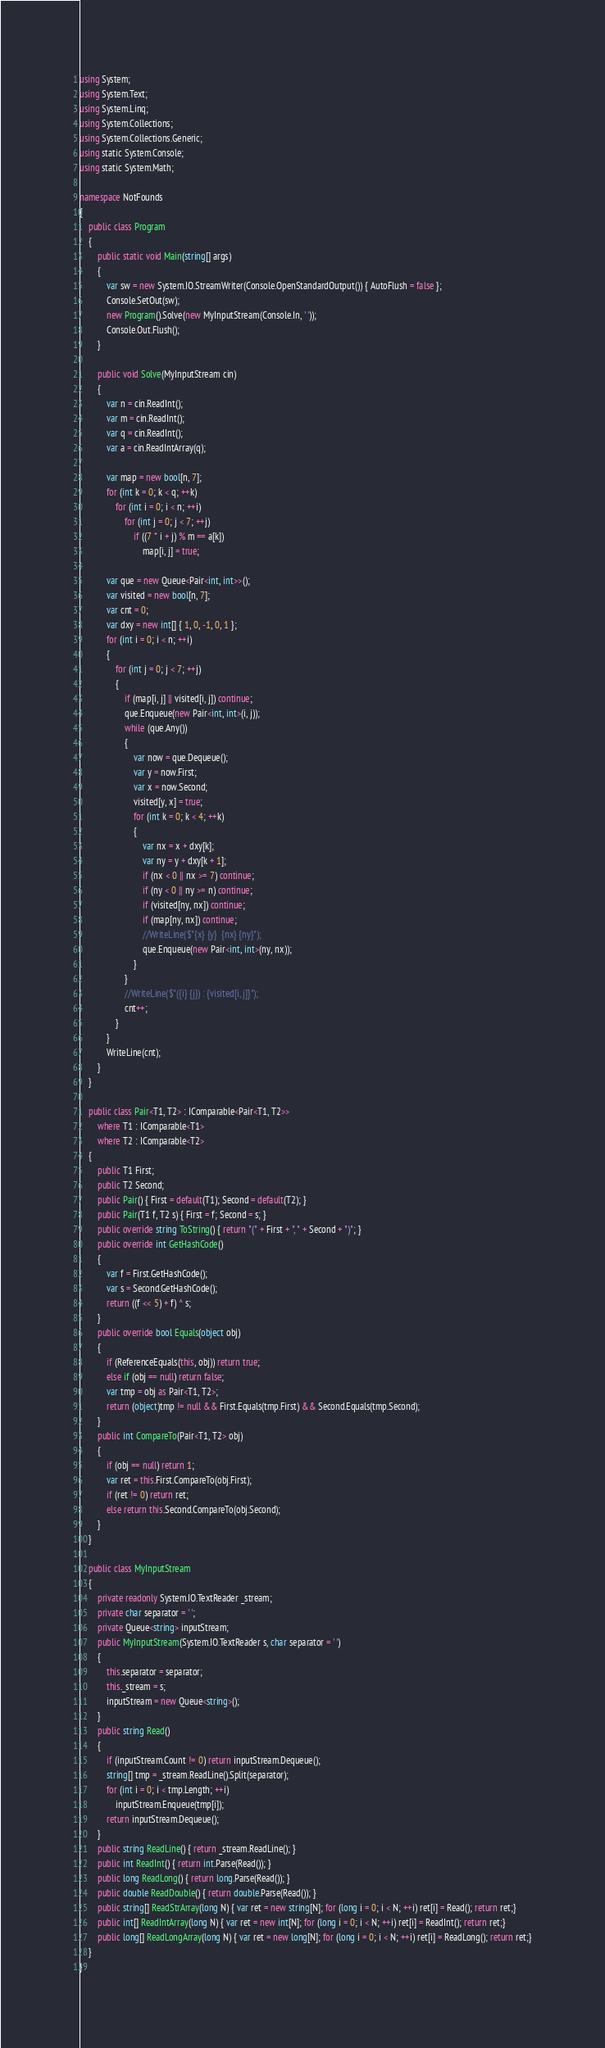Convert code to text. <code><loc_0><loc_0><loc_500><loc_500><_C#_>using System;
using System.Text;
using System.Linq;
using System.Collections;
using System.Collections.Generic;
using static System.Console;
using static System.Math;

namespace NotFounds
{
    public class Program
    {
        public static void Main(string[] args)
        {
            var sw = new System.IO.StreamWriter(Console.OpenStandardOutput()) { AutoFlush = false };
            Console.SetOut(sw);
            new Program().Solve(new MyInputStream(Console.In, ' '));
            Console.Out.Flush();
        }

        public void Solve(MyInputStream cin)
        {
            var n = cin.ReadInt();
            var m = cin.ReadInt();
            var q = cin.ReadInt();
            var a = cin.ReadIntArray(q);

            var map = new bool[n, 7];
            for (int k = 0; k < q; ++k)
                for (int i = 0; i < n; ++i)
                    for (int j = 0; j < 7; ++j)
                        if ((7 * i + j) % m == a[k])
                            map[i, j] = true;

            var que = new Queue<Pair<int, int>>();
            var visited = new bool[n, 7];
            var cnt = 0;
            var dxy = new int[] { 1, 0, -1, 0, 1 };
            for (int i = 0; i < n; ++i)
            {
                for (int j = 0; j < 7; ++j)
                {
                    if (map[i, j] || visited[i, j]) continue;
                    que.Enqueue(new Pair<int, int>(i, j));
                    while (que.Any())
                    {
                        var now = que.Dequeue();
                        var y = now.First;
                        var x = now.Second;
                        visited[y, x] = true;
                        for (int k = 0; k < 4; ++k)
                        {
                            var nx = x + dxy[k];
                            var ny = y + dxy[k + 1];
                            if (nx < 0 || nx >= 7) continue;
                            if (ny < 0 || ny >= n) continue;
                            if (visited[ny, nx]) continue;
                            if (map[ny, nx]) continue;
                            //WriteLine($"{x} {y}  {nx} {ny}");
                            que.Enqueue(new Pair<int, int>(ny, nx));
                        }
                    }
                    //WriteLine($"({i} {j}) : {visited[i, j]}");
                    cnt++;
                }
            }
            WriteLine(cnt);
        }
    }

    public class Pair<T1, T2> : IComparable<Pair<T1, T2>>
        where T1 : IComparable<T1>
        where T2 : IComparable<T2>
    {
        public T1 First;
        public T2 Second;
        public Pair() { First = default(T1); Second = default(T2); }
        public Pair(T1 f, T2 s) { First = f; Second = s; }
        public override string ToString() { return "(" + First + ", " + Second + ")"; }
        public override int GetHashCode()
        {
            var f = First.GetHashCode();
            var s = Second.GetHashCode();
            return ((f << 5) + f) ^ s;
        }
        public override bool Equals(object obj)
        {
            if (ReferenceEquals(this, obj)) return true;
            else if (obj == null) return false;
            var tmp = obj as Pair<T1, T2>;
            return (object)tmp != null && First.Equals(tmp.First) && Second.Equals(tmp.Second);
        }
        public int CompareTo(Pair<T1, T2> obj)
        {
            if (obj == null) return 1;
            var ret = this.First.CompareTo(obj.First);
            if (ret != 0) return ret;
            else return this.Second.CompareTo(obj.Second);
        }
    }

    public class MyInputStream
    {
        private readonly System.IO.TextReader _stream;
        private char separator = ' ';
        private Queue<string> inputStream;
        public MyInputStream(System.IO.TextReader s, char separator = ' ')
        {
            this.separator = separator;
            this._stream = s;
            inputStream = new Queue<string>();
        }
        public string Read()
        {
            if (inputStream.Count != 0) return inputStream.Dequeue();
            string[] tmp = _stream.ReadLine().Split(separator);
            for (int i = 0; i < tmp.Length; ++i)
                inputStream.Enqueue(tmp[i]);
            return inputStream.Dequeue();
        }
        public string ReadLine() { return _stream.ReadLine(); }
        public int ReadInt() { return int.Parse(Read()); }
        public long ReadLong() { return long.Parse(Read()); }
        public double ReadDouble() { return double.Parse(Read()); }
        public string[] ReadStrArray(long N) { var ret = new string[N]; for (long i = 0; i < N; ++i) ret[i] = Read(); return ret;}
        public int[] ReadIntArray(long N) { var ret = new int[N]; for (long i = 0; i < N; ++i) ret[i] = ReadInt(); return ret;}
        public long[] ReadLongArray(long N) { var ret = new long[N]; for (long i = 0; i < N; ++i) ret[i] = ReadLong(); return ret;}
    }
}
</code> 